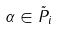<formula> <loc_0><loc_0><loc_500><loc_500>\alpha \in \tilde { P } _ { i }</formula> 